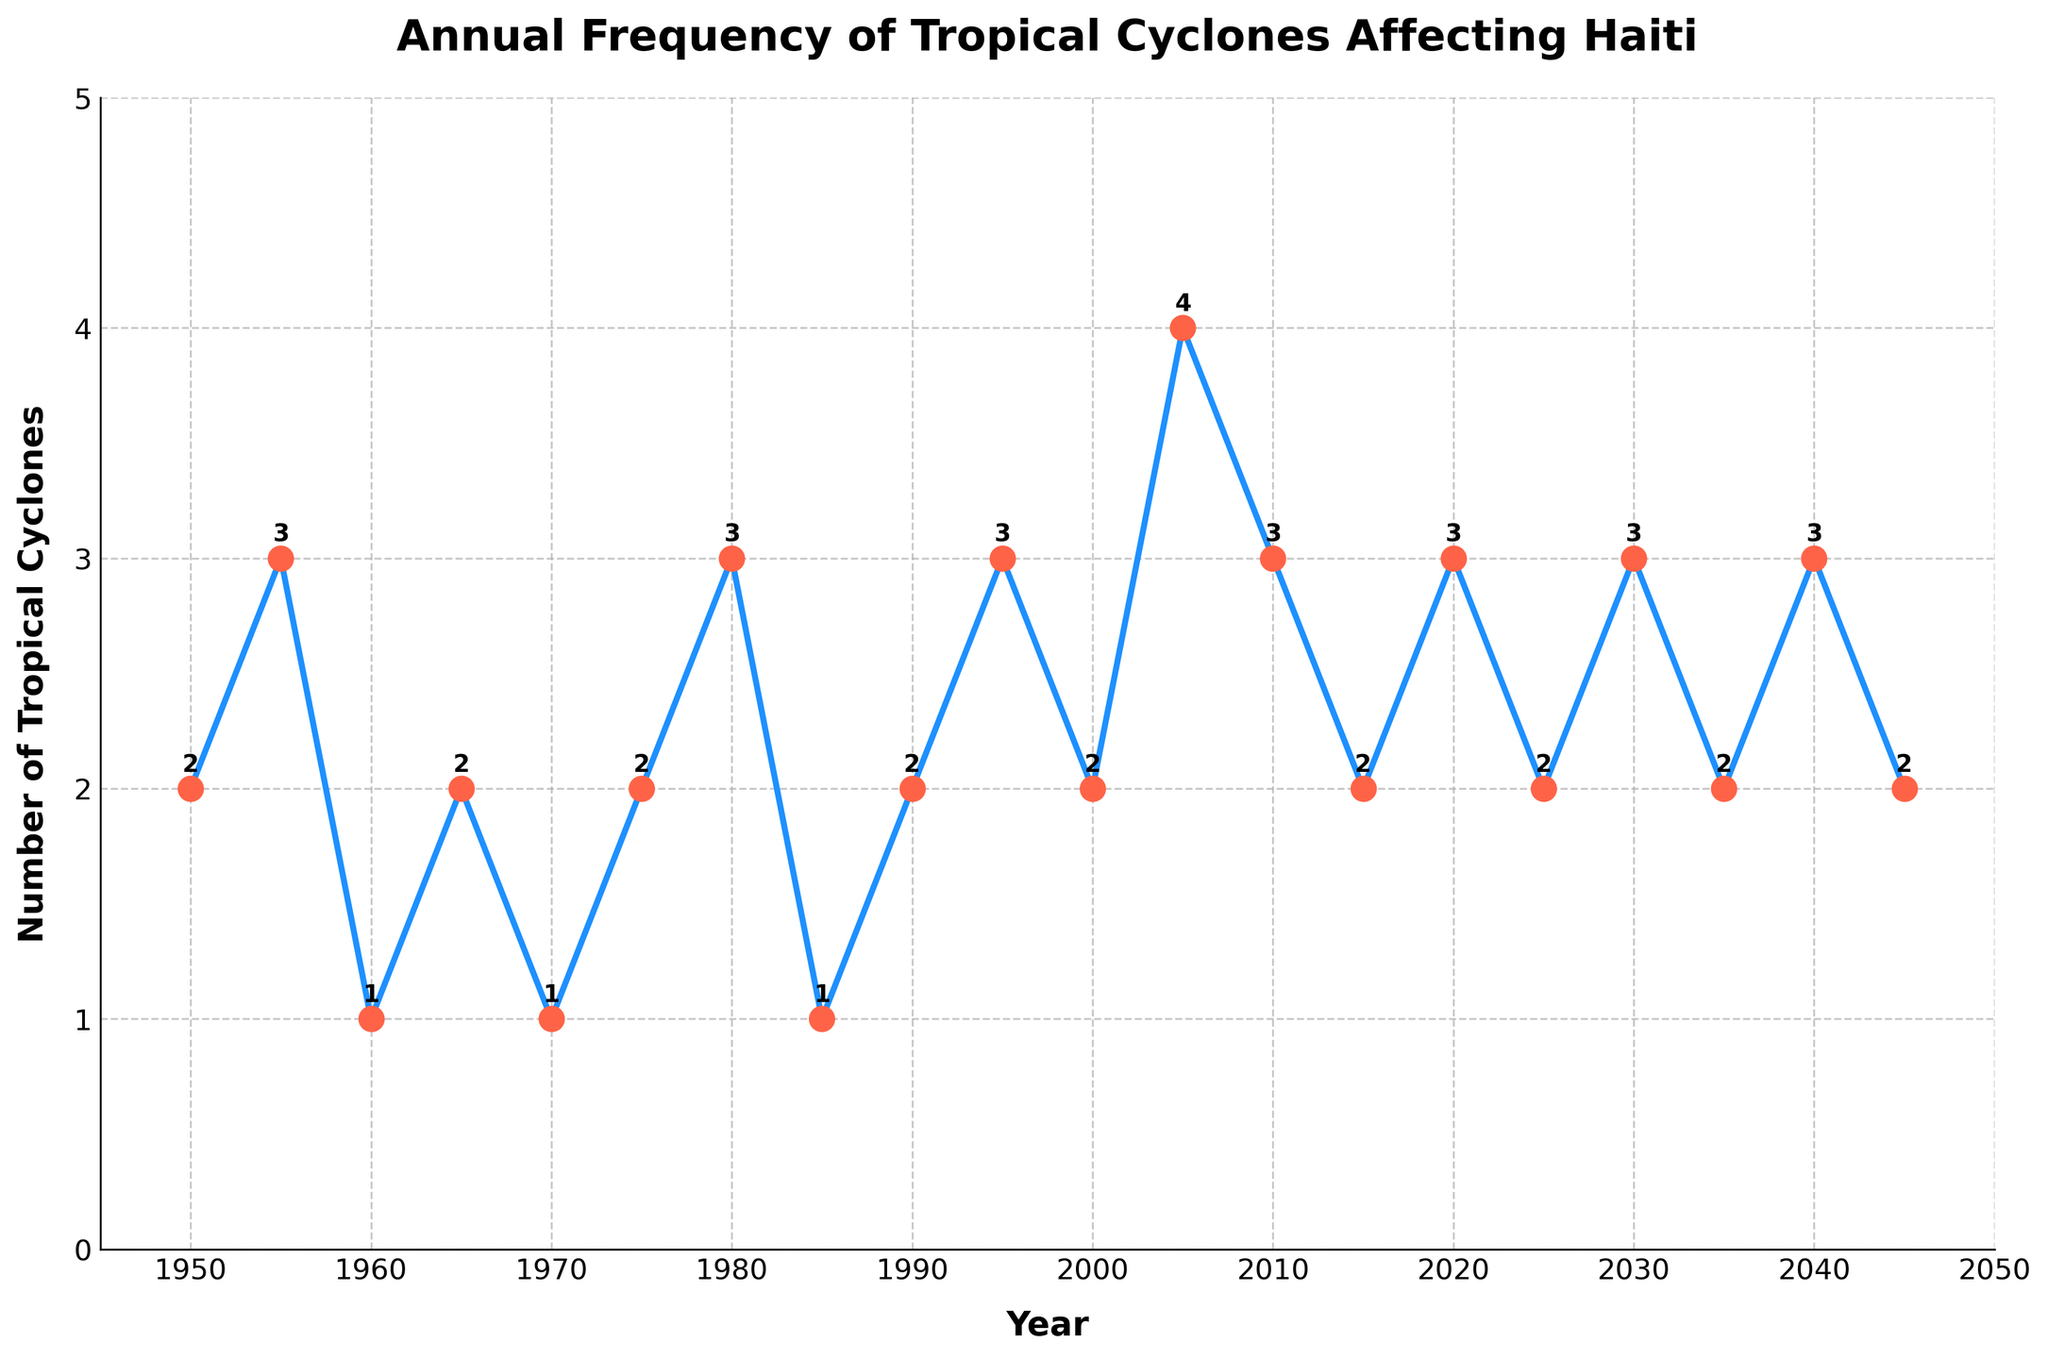Which year had the highest number of tropical cyclones affecting Haiti? By observing the peaks in the line plot, the year with the highest peak corresponds to 2005.
Answer: 2005 What is the average number of tropical cyclones affecting Haiti per year from 2000 to 2025? The years 2000, 2005, 2010, 2015, 2020, and 2025 have respective cyclone counts of 2, 4, 3, 2, 3, and 2. Summing these: 2 + 4 + 3 + 2 + 3 + 2 = 16. Dividing by the 6 years gives the average: 16 / 6 ≈ 2.67.
Answer: about 2.67 In which year(s) did Haiti experience 1 tropical cyclone? By looking at the data points on the line plot where the value is 1, these correspond to the years 1960, 1970, and 1985.
Answer: 1960, 1970, 1985 Comparing 1955 and 1975, in which year did Haiti have more tropical cyclones? Looking at the line plot, 1955 has a higher point with 3 cyclones compared to 1975 which had 2.
Answer: 1955 How many years were observed with exactly 2 tropical cyclones affecting Haiti? By counting the number of years where the data points equal 2, the years are 1950, 1965, 1975, 1990, 2000, 2015, 2025, 2035, and 2045, resulting in 9 years.
Answer: 9 What is the total number of tropical cyclones affecting Haiti from 1980 to 2005? Summing the values for the years 1980, 1985, 1990, 1995, 2000, and 2005: 3 + 1 + 2 + 3 + 2 + 4 = 15.
Answer: 15 How does the number of tropical cyclones in 2020 compare to that in 1995? Both 2020 and 1995 have data points indicating 3 tropical cyclones.
Answer: equal What was the increase in the number of tropical cyclones from 2000 to 2005? The number of cyclones in 2000 is 2 and in 2005 is 4. The increase is 4 - 2 = 2.
Answer: 2 Is there any year when no tropical cyclones affected Haiti? The line plot shows that all points are above zero, so there is no year with zero tropical cyclones.
Answer: No What trend do you observe in the number of tropical cyclones affecting Haiti from 2005 to 2045? From 2005 to 2045, the line plot shows a fluctuating trend between 2 and 3 tropical cyclones each year, showing no clear increase or decrease over time.
Answer: Fluctuating between 2 and 3 